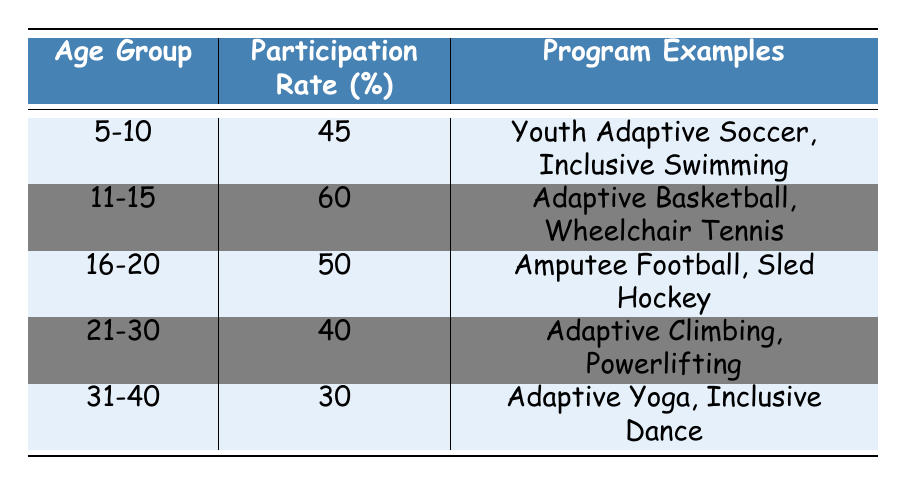What is the participation rate for the age group 11-15? The table shows the participation rate for each age group. For the age group 11-15, the participation rate is listed directly as 60%.
Answer: 60 Which age group has the highest participation rate? By examining the participation rates for all age groups in the table, the age group 11-15 has the highest rate at 60%.
Answer: 11-15 What is the average participation rate for the age groups 16-20 and 21-30? The participation rates for the groups 16-20 and 21-30 are 50% and 40%, respectively. To find the average, we add these rates: 50 + 40 = 90, and then divide by 2 (the number of age groups), so 90/2 = 45%.
Answer: 45 Is the participation rate for the age group 31-40 greater than 40%? The table shows that the participation rate for the age group 31-40 is 30%. Since 30% is less than 40%, the answer is no.
Answer: No Which programs are listed for the age group 5-10? For the age group 5-10, the table provides two program examples: Youth Adaptive Soccer and Inclusive Swimming.
Answer: Youth Adaptive Soccer, Inclusive Swimming If we combine the participation rates of all age groups, what is the total participation rate? The rates are 45% (5-10) + 60% (11-15) + 50% (16-20) + 40% (21-30) + 30% (31-40) = 225%. Therefore, the total participation rate is 225%.
Answer: 225 What age group has a participation rate that is less than 35%? Reviewing the table, the age group 31-40 has a participation rate of 30%, which is less than 35%. This is the only age group in the table with a rate below that threshold.
Answer: 31-40 Is the participation rate for age group 21-30 more than the average participation rate for all age groups? The total participation rates sum to 225% for the five age groups, and dividing this value by 5 gives an average of 45%. The participation rate for the 21-30 age group is 40%, which is less than 45%. Thus, the answer is no.
Answer: No 